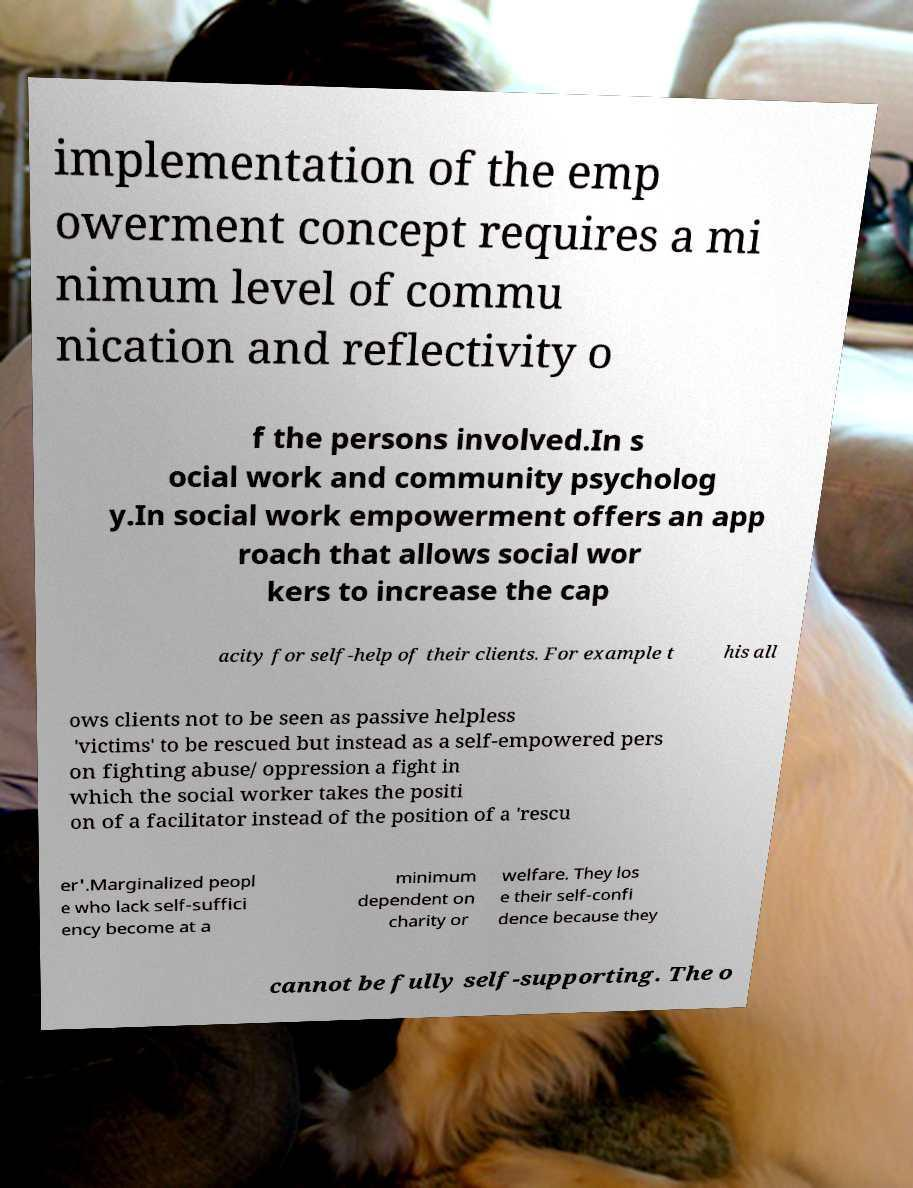What messages or text are displayed in this image? I need them in a readable, typed format. implementation of the emp owerment concept requires a mi nimum level of commu nication and reflectivity o f the persons involved.In s ocial work and community psycholog y.In social work empowerment offers an app roach that allows social wor kers to increase the cap acity for self-help of their clients. For example t his all ows clients not to be seen as passive helpless 'victims' to be rescued but instead as a self-empowered pers on fighting abuse/ oppression a fight in which the social worker takes the positi on of a facilitator instead of the position of a 'rescu er'.Marginalized peopl e who lack self-suffici ency become at a minimum dependent on charity or welfare. They los e their self-confi dence because they cannot be fully self-supporting. The o 